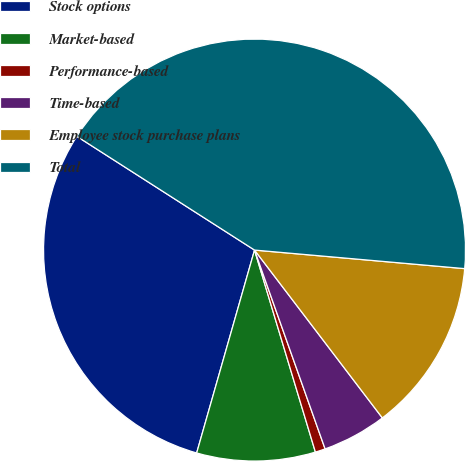<chart> <loc_0><loc_0><loc_500><loc_500><pie_chart><fcel>Stock options<fcel>Market-based<fcel>Performance-based<fcel>Time-based<fcel>Employee stock purchase plans<fcel>Total<nl><fcel>29.64%<fcel>9.08%<fcel>0.77%<fcel>4.93%<fcel>13.24%<fcel>42.34%<nl></chart> 